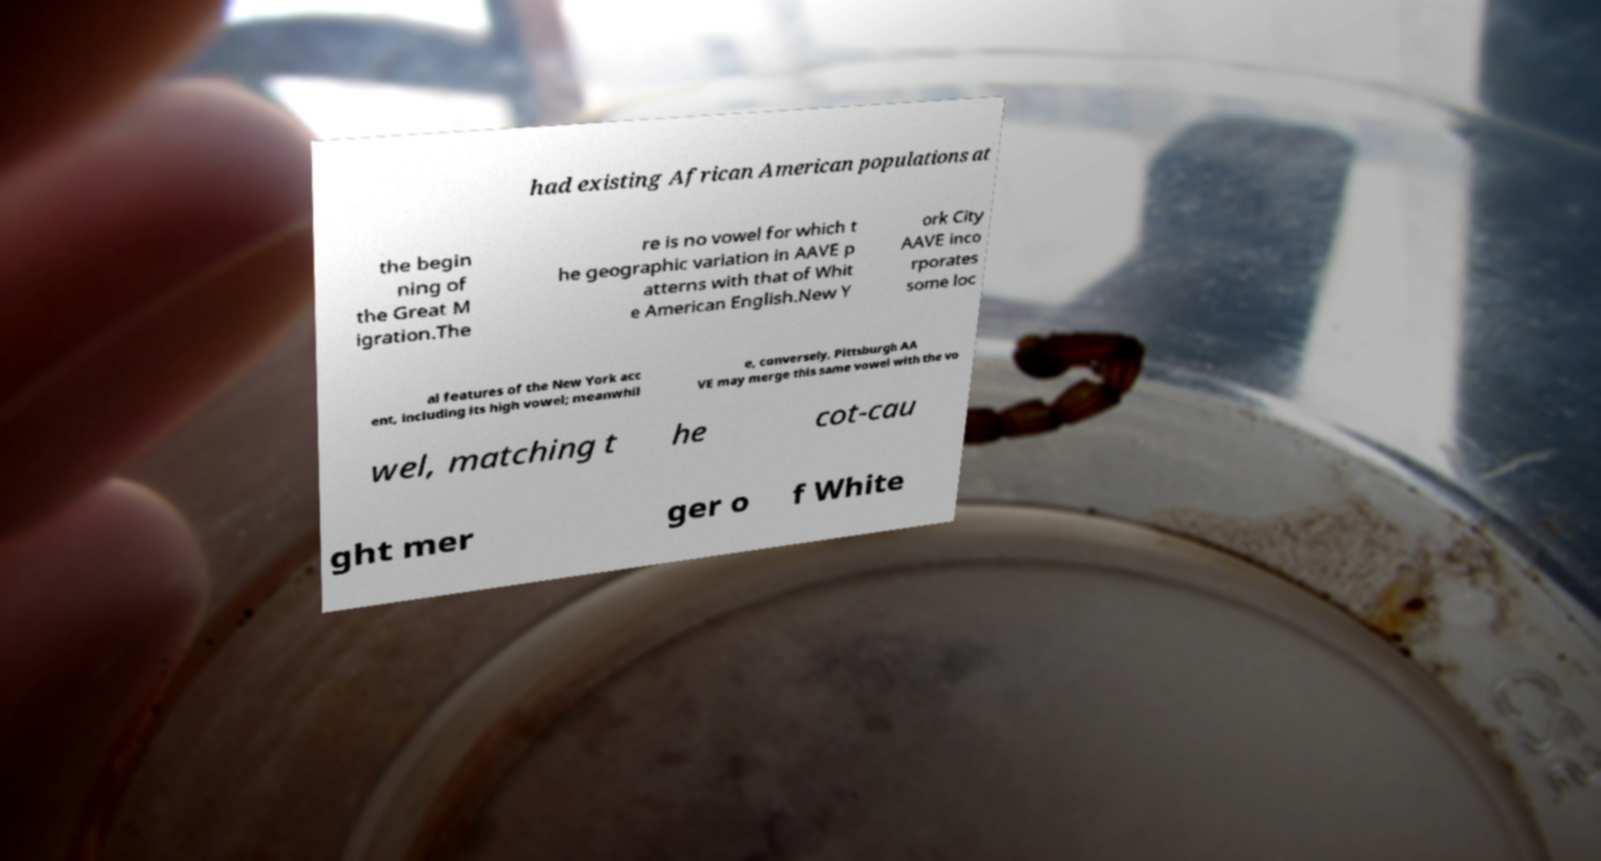There's text embedded in this image that I need extracted. Can you transcribe it verbatim? had existing African American populations at the begin ning of the Great M igration.The re is no vowel for which t he geographic variation in AAVE p atterns with that of Whit e American English.New Y ork City AAVE inco rporates some loc al features of the New York acc ent, including its high vowel; meanwhil e, conversely, Pittsburgh AA VE may merge this same vowel with the vo wel, matching t he cot-cau ght mer ger o f White 